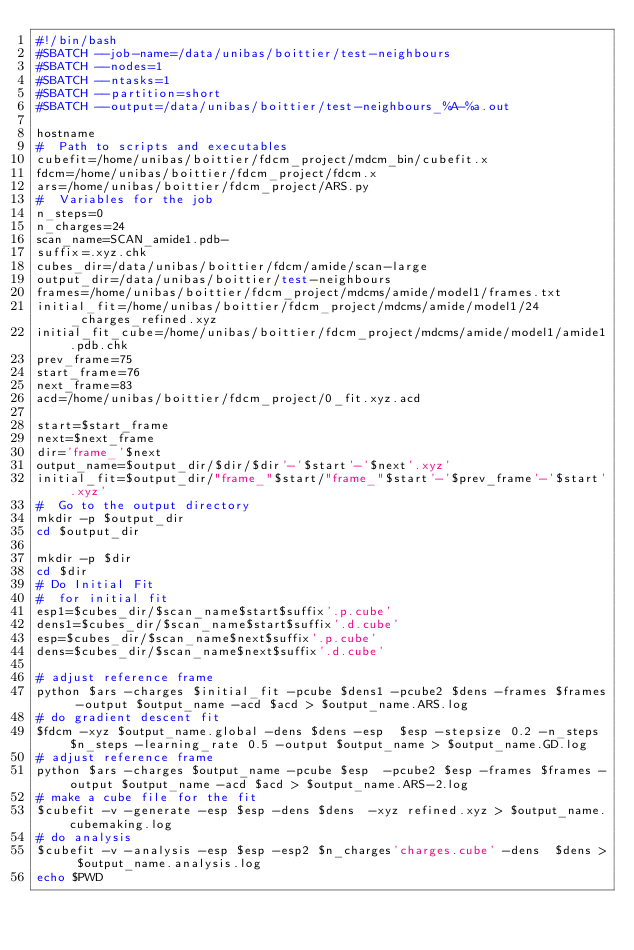Convert code to text. <code><loc_0><loc_0><loc_500><loc_500><_Bash_>#!/bin/bash
#SBATCH --job-name=/data/unibas/boittier/test-neighbours
#SBATCH --nodes=1
#SBATCH --ntasks=1
#SBATCH --partition=short
#SBATCH --output=/data/unibas/boittier/test-neighbours_%A-%a.out

hostname
#  Path to scripts and executables
cubefit=/home/unibas/boittier/fdcm_project/mdcm_bin/cubefit.x
fdcm=/home/unibas/boittier/fdcm_project/fdcm.x
ars=/home/unibas/boittier/fdcm_project/ARS.py
#  Variables for the job
n_steps=0
n_charges=24
scan_name=SCAN_amide1.pdb-
suffix=.xyz.chk
cubes_dir=/data/unibas/boittier/fdcm/amide/scan-large
output_dir=/data/unibas/boittier/test-neighbours
frames=/home/unibas/boittier/fdcm_project/mdcms/amide/model1/frames.txt
initial_fit=/home/unibas/boittier/fdcm_project/mdcms/amide/model1/24_charges_refined.xyz
initial_fit_cube=/home/unibas/boittier/fdcm_project/mdcms/amide/model1/amide1.pdb.chk
prev_frame=75
start_frame=76
next_frame=83
acd=/home/unibas/boittier/fdcm_project/0_fit.xyz.acd

start=$start_frame
next=$next_frame
dir='frame_'$next
output_name=$output_dir/$dir/$dir'-'$start'-'$next'.xyz'
initial_fit=$output_dir/"frame_"$start/"frame_"$start'-'$prev_frame'-'$start'.xyz'
#  Go to the output directory
mkdir -p $output_dir
cd $output_dir

mkdir -p $dir
cd $dir
# Do Initial Fit
#  for initial fit
esp1=$cubes_dir/$scan_name$start$suffix'.p.cube'
dens1=$cubes_dir/$scan_name$start$suffix'.d.cube'
esp=$cubes_dir/$scan_name$next$suffix'.p.cube'
dens=$cubes_dir/$scan_name$next$suffix'.d.cube'

# adjust reference frame
python $ars -charges $initial_fit -pcube $dens1 -pcube2 $dens -frames $frames -output $output_name -acd $acd > $output_name.ARS.log
# do gradient descent fit
$fdcm -xyz $output_name.global -dens $dens -esp  $esp -stepsize 0.2 -n_steps $n_steps -learning_rate 0.5 -output $output_name > $output_name.GD.log
# adjust reference frame
python $ars -charges $output_name -pcube $esp  -pcube2 $esp -frames $frames -output $output_name -acd $acd > $output_name.ARS-2.log
# make a cube file for the fit
$cubefit -v -generate -esp $esp -dens $dens  -xyz refined.xyz > $output_name.cubemaking.log
# do analysis
$cubefit -v -analysis -esp $esp -esp2 $n_charges'charges.cube' -dens  $dens > $output_name.analysis.log
echo $PWD




</code> 